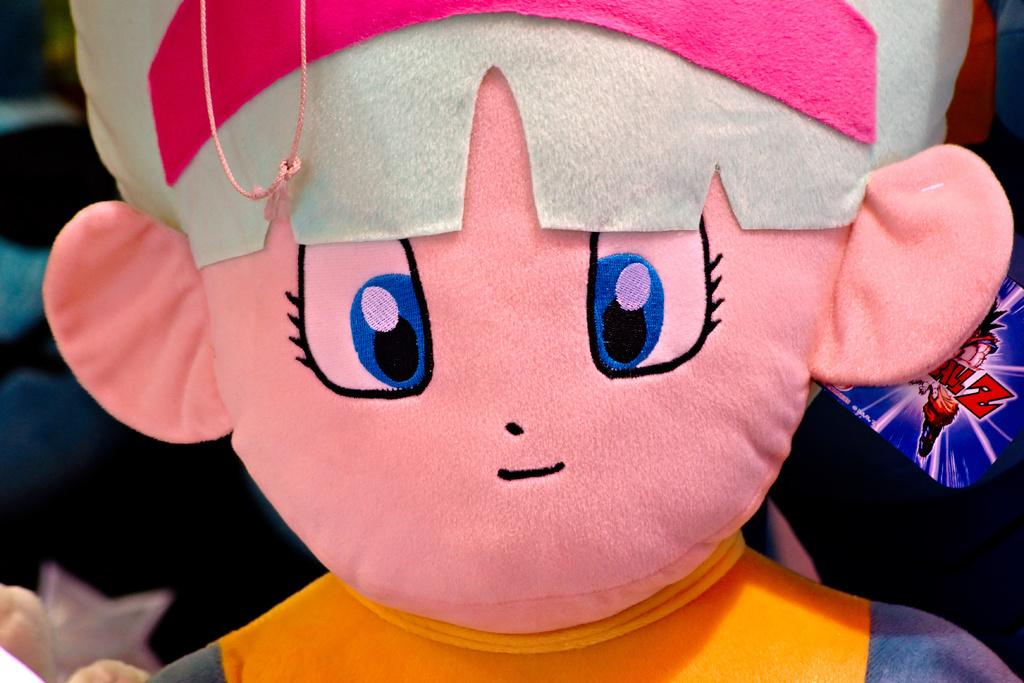What object in the image appears to be incomplete or cut off? The toy in the image is truncated. What type of bag is visible in the image? There is no bag present in the image; it only features a truncated toy. What type of sponge can be seen in the image? There is no sponge present in the image; it only features a truncated toy. 